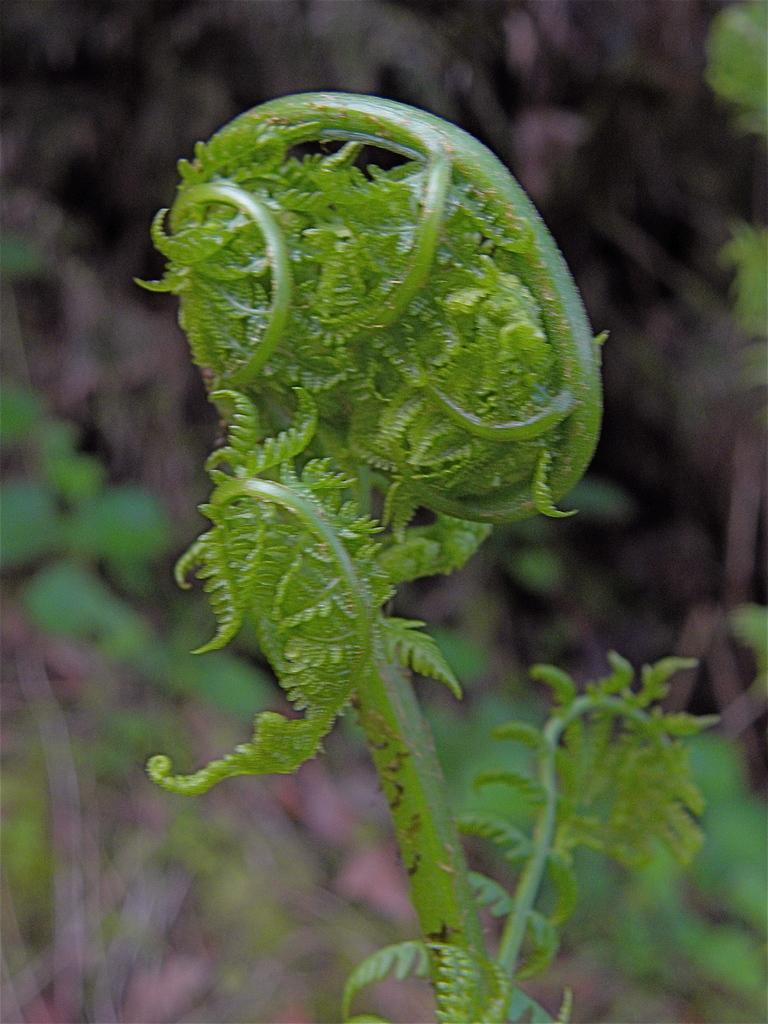What is the main subject in the foreground of the image? There is a plant in the foreground of the image. Can you describe the background of the image? The background of the image is blurry. How many frogs are sitting on the soda can in the image? There is no soda can or frogs present in the image. 